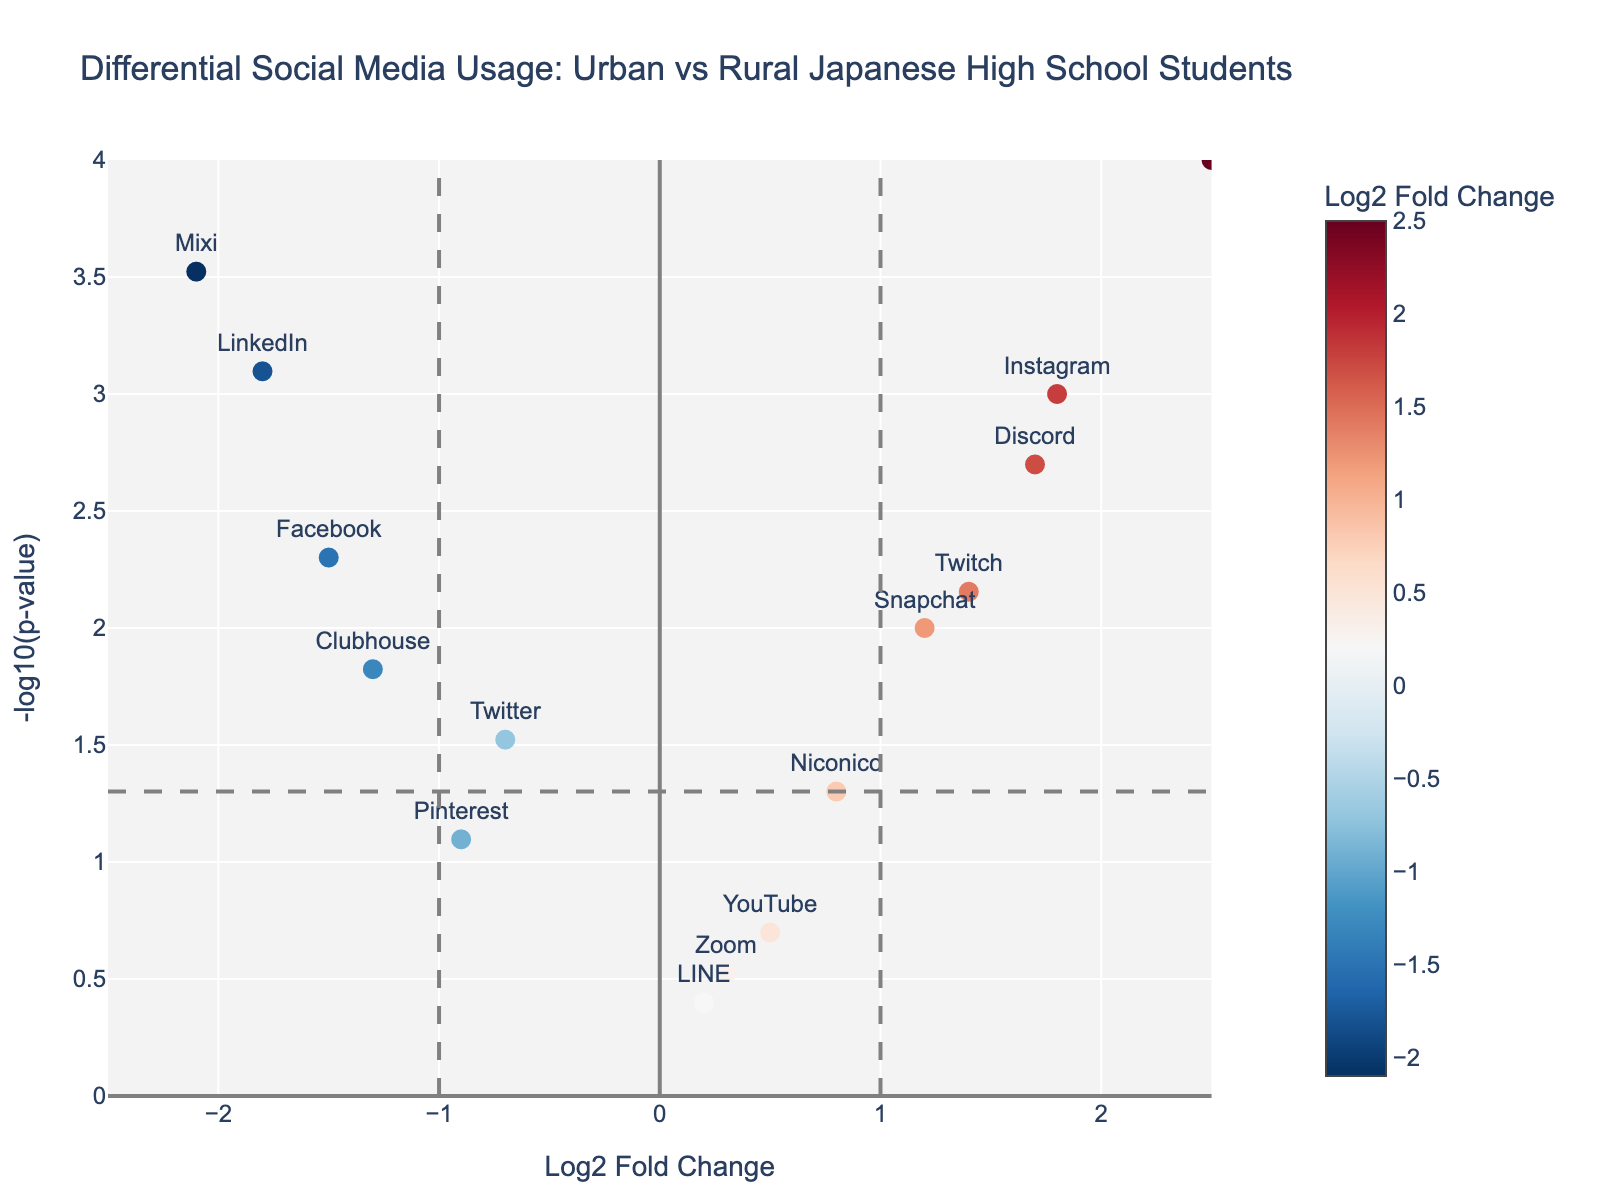What does the title of the plot say? The title of the plot is displayed at the top and reads "Differential Social Media Usage: Urban vs Rural Japanese High School Students". This describes the content and focus of the plot.
Answer: Differential Social Media Usage: Urban vs Rural Japanese High School Students How many data points are plotted on the chart? There are 15 data points plotted on the chart. Each point represents a social media platform.
Answer: 15 Which social media platform shows the highest over-utilization in urban areas? The most over-utilized platform in urban areas has the highest Log2 Fold Change value. TikTok has the highest Log2 Fold Change value of 2.5.
Answer: TikTok Which platform is significantly under-utilized in rural areas and has the most negative Log2 Fold Change? The most under-utilized platform in rural areas has the most negative Log2 Fold Change and a significant p-value (below the threshold line). Mixi has the most negative Log2 Fold Change at -2.1 with a significant p-value.
Answer: Mixi What is the threshold p-value level depicted by the horizontal dashed line? The horizontal dashed line represents the threshold for the significance level at p-value = 0.05. The corresponding -log10(p-value) is -log10(0.05) which equals 1.301.
Answer: 0.05 How many platforms have a p-value lower than 0.05 and a positive Log2 Fold Change? To determine this, count the platforms above the horizontal dashed line and to the right of the vertical line at Log2 Fold Change = 0. SnapChat, Instagram, TikTok, Discord, and Twitch meet these criteria.
Answer: 5 Compare the Log2 Fold Change values of Facebook and LinkedIn. Which one is more under-utilized in rural areas? Both Facebook and LinkedIn have negative Log2 Fold Change values. Compare their values: Facebook (-1.5) vs. LinkedIn (-1.8). LinkedIn is more under-utilized.
Answer: LinkedIn Which social media platforms have a Log2 Fold Change close to zero and are therefore similarly used in both urban and rural areas? Platforms near a Log2 Fold Change of 0 indicate similar usage in urban and rural areas. LINE (0.2) and Zoom (0.3) are close to zero.
Answer: LINE, Zoom Are there any platforms that are under-utilized in rural areas but do not have a significant p-value? Look for platforms with negative Log2 Fold Change values below the significance threshold (-log10(0.05)). Pinterest has a Log2 Fold Change of -0.9 and a p-value of 0.08, which is not significant.
Answer: Pinterest Which platform has the highest p-value and what does its usage difference indicate? Identify the platform with the highest p-value. LINE has a p-value of 0.4. Its Log2 Fold Change of 0.2 indicates minimal usage difference between urban and rural areas.
Answer: LINE 